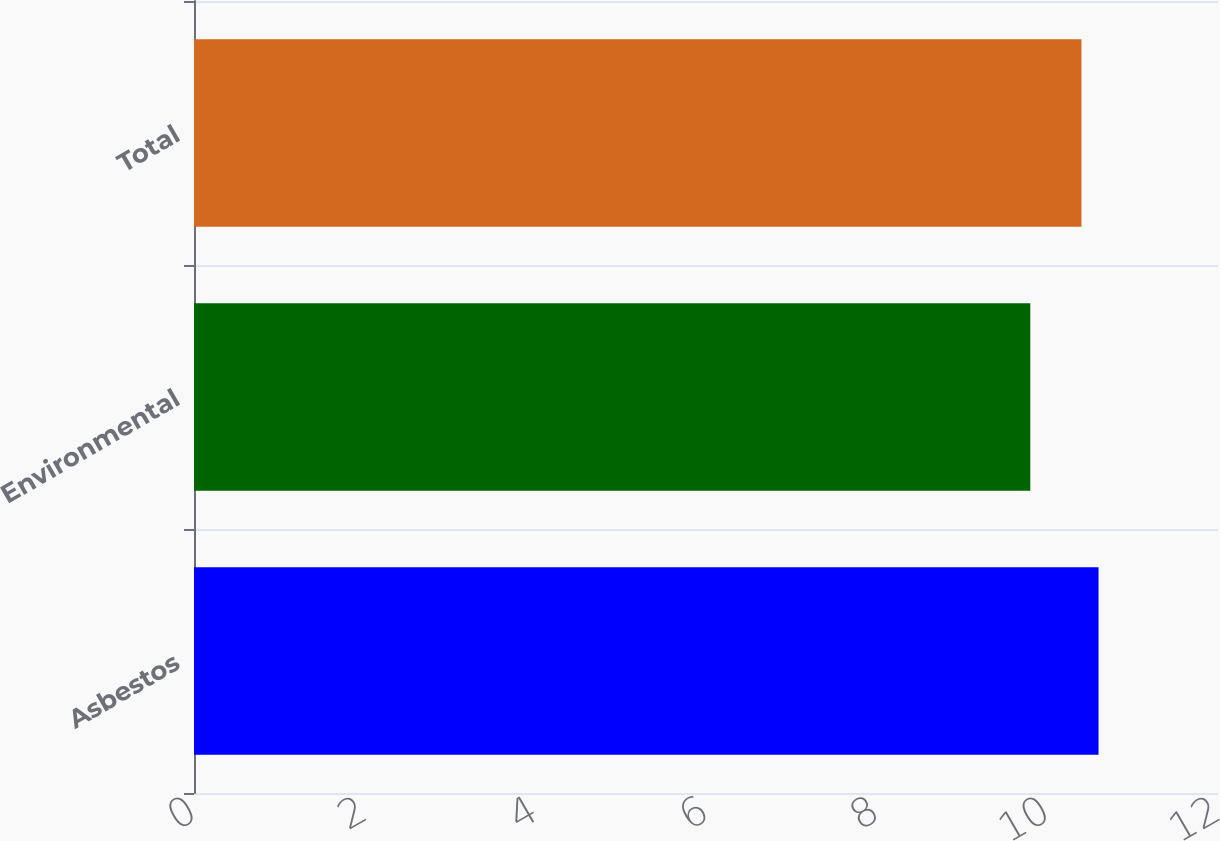Convert chart. <chart><loc_0><loc_0><loc_500><loc_500><bar_chart><fcel>Asbestos<fcel>Environmental<fcel>Total<nl><fcel>10.6<fcel>9.8<fcel>10.4<nl></chart> 